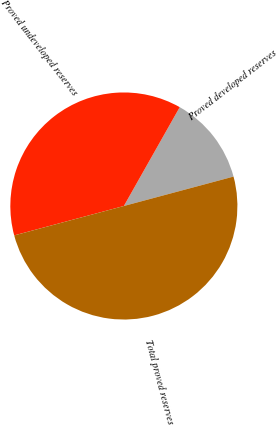Convert chart to OTSL. <chart><loc_0><loc_0><loc_500><loc_500><pie_chart><fcel>Proved developed reserves<fcel>Proved undeveloped reserves<fcel>Total proved reserves<nl><fcel>12.64%<fcel>37.36%<fcel>50.0%<nl></chart> 